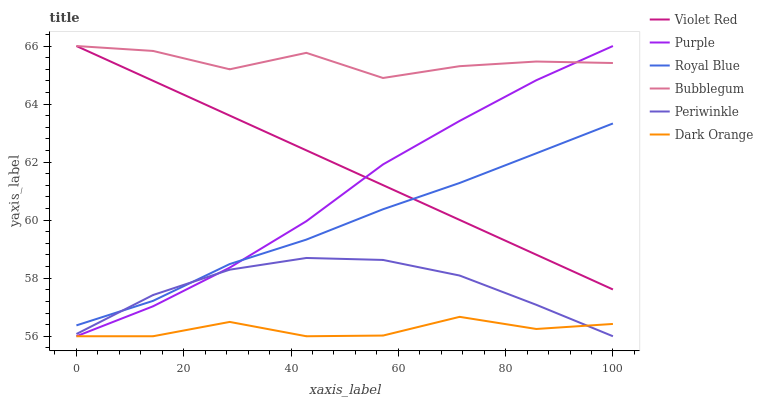Does Violet Red have the minimum area under the curve?
Answer yes or no. No. Does Violet Red have the maximum area under the curve?
Answer yes or no. No. Is Purple the smoothest?
Answer yes or no. No. Is Purple the roughest?
Answer yes or no. No. Does Violet Red have the lowest value?
Answer yes or no. No. Does Royal Blue have the highest value?
Answer yes or no. No. Is Periwinkle less than Bubblegum?
Answer yes or no. Yes. Is Violet Red greater than Dark Orange?
Answer yes or no. Yes. Does Periwinkle intersect Bubblegum?
Answer yes or no. No. 